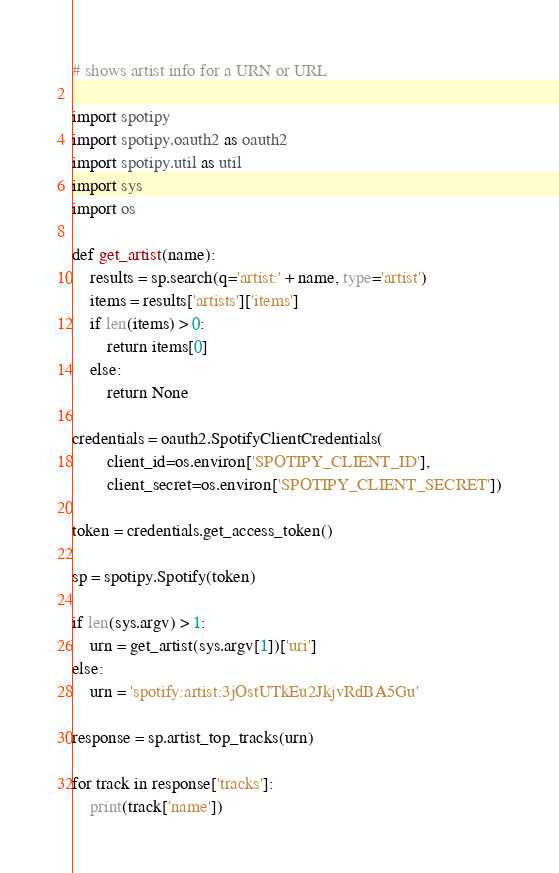Convert code to text. <code><loc_0><loc_0><loc_500><loc_500><_Python_># shows artist info for a URN or URL

import spotipy
import spotipy.oauth2 as oauth2
import spotipy.util as util
import sys
import os

def get_artist(name):
    results = sp.search(q='artist:' + name, type='artist')
    items = results['artists']['items']
    if len(items) > 0:
        return items[0]
    else:
        return None

credentials = oauth2.SpotifyClientCredentials(
        client_id=os.environ['SPOTIPY_CLIENT_ID'],
        client_secret=os.environ['SPOTIPY_CLIENT_SECRET'])

token = credentials.get_access_token()

sp = spotipy.Spotify(token)

if len(sys.argv) > 1:
    urn = get_artist(sys.argv[1])['uri']
else:
    urn = 'spotify:artist:3jOstUTkEu2JkjvRdBA5Gu'

response = sp.artist_top_tracks(urn)

for track in response['tracks']:
    print(track['name'])
</code> 